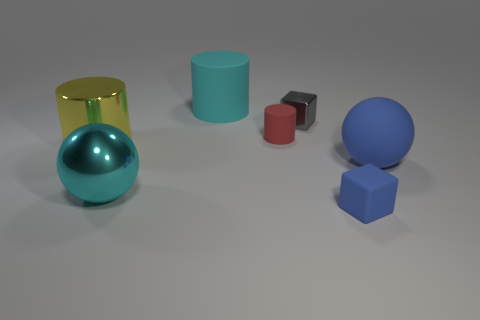Add 2 large spheres. How many objects exist? 9 Subtract all cubes. How many objects are left? 5 Add 5 metal balls. How many metal balls are left? 6 Add 2 matte cylinders. How many matte cylinders exist? 4 Subtract 0 green spheres. How many objects are left? 7 Subtract all cubes. Subtract all gray metal blocks. How many objects are left? 4 